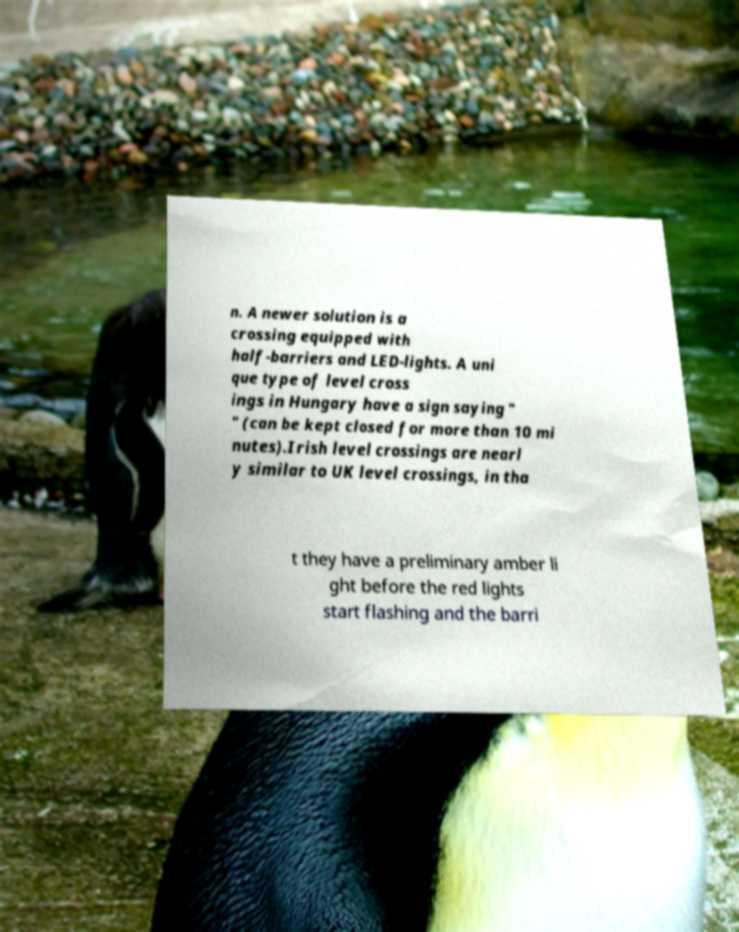Could you extract and type out the text from this image? n. A newer solution is a crossing equipped with half-barriers and LED-lights. A uni que type of level cross ings in Hungary have a sign saying " " (can be kept closed for more than 10 mi nutes).Irish level crossings are nearl y similar to UK level crossings, in tha t they have a preliminary amber li ght before the red lights start flashing and the barri 